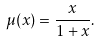Convert formula to latex. <formula><loc_0><loc_0><loc_500><loc_500>\mu ( x ) = \frac { x } { 1 + x } .</formula> 